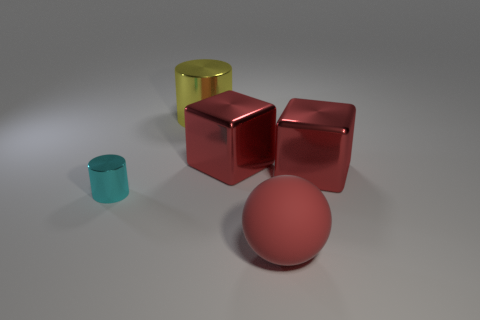Add 1 blue shiny things. How many objects exist? 6 Subtract all blocks. How many objects are left? 3 Subtract all big red balls. Subtract all large red rubber balls. How many objects are left? 3 Add 1 cyan shiny things. How many cyan shiny things are left? 2 Add 5 large cyan shiny cylinders. How many large cyan shiny cylinders exist? 5 Subtract 1 red balls. How many objects are left? 4 